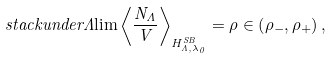<formula> <loc_0><loc_0><loc_500><loc_500>\ s t a c k u n d e r { \Lambda } { \lim } \left \langle \frac { N _ { \Lambda } } { V } \right \rangle _ { H _ { \Lambda , \lambda _ { 0 } } ^ { S B } } = \rho \in \left ( \rho _ { - } , \rho _ { + } \right ) , \text { }</formula> 